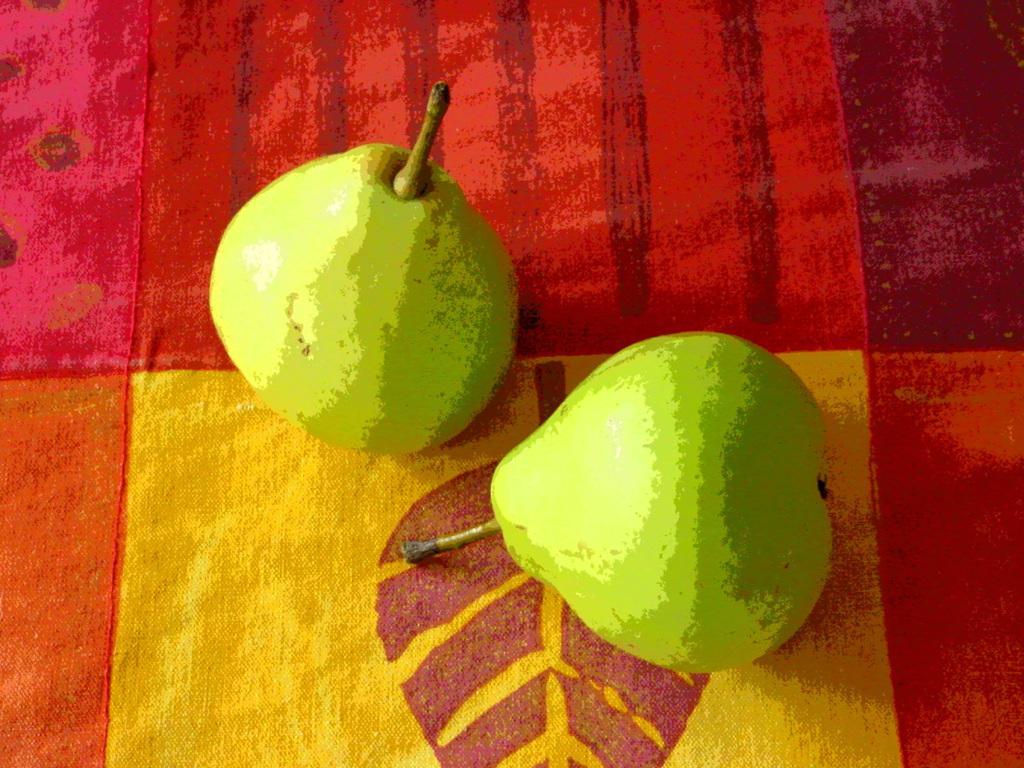Could you give a brief overview of what you see in this image? In the picture we can see a cloth which is red and some part yellow in color on it, we can see two fruits which are green in color. 